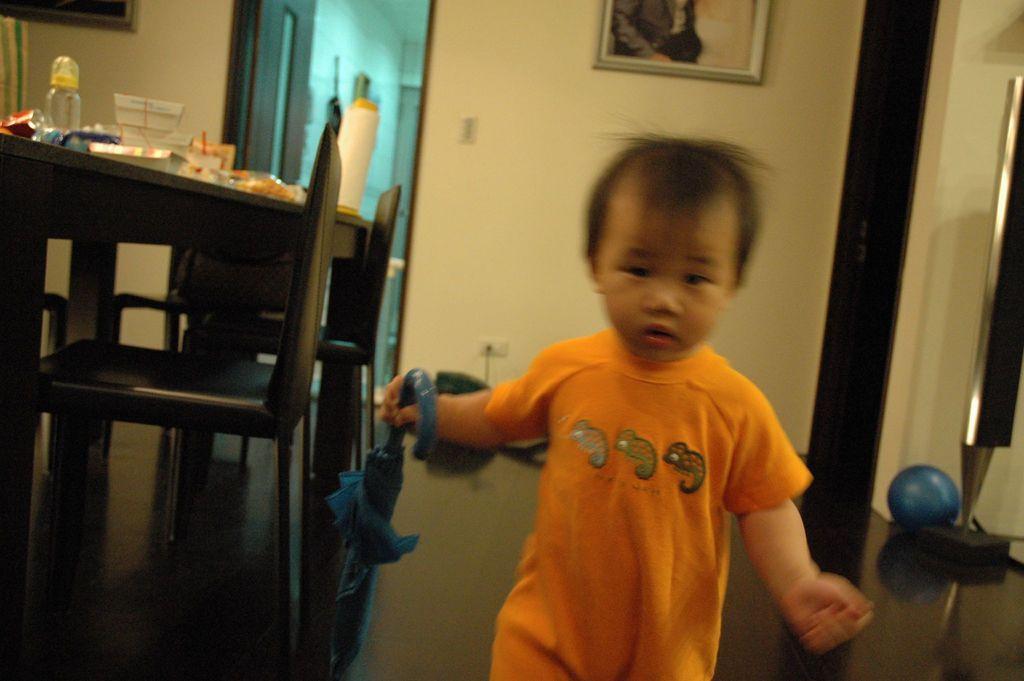Describe this image in one or two sentences. In this image, there is kid wearing clothes and holding an umbrella with his hand. There is a table and chairs on the left of the image. This table contains bottle and boxes. There is a door which is attached to the wall. 